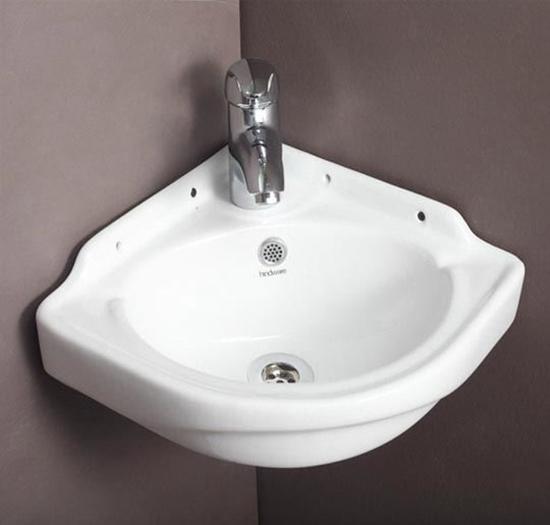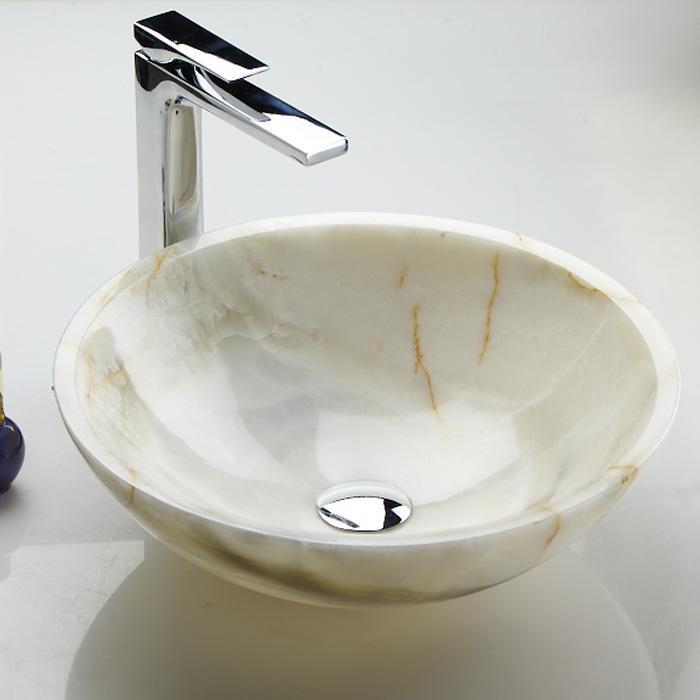The first image is the image on the left, the second image is the image on the right. Examine the images to the left and right. Is the description "The sink on the right has a rectangular shape." accurate? Answer yes or no. No. 